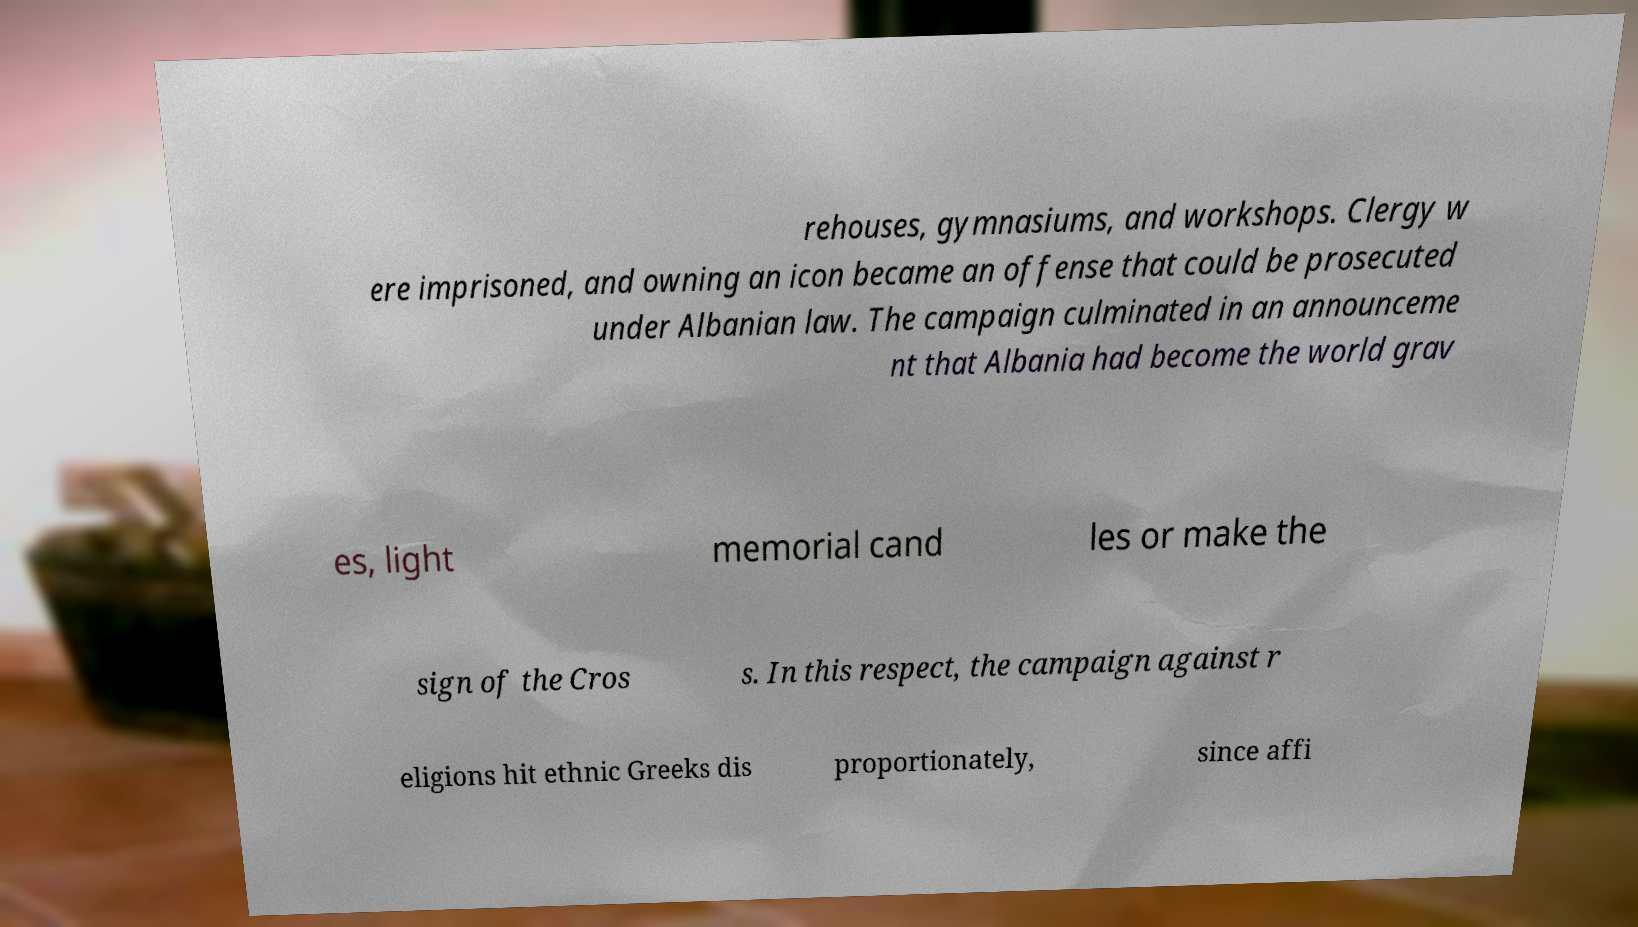Can you read and provide the text displayed in the image?This photo seems to have some interesting text. Can you extract and type it out for me? rehouses, gymnasiums, and workshops. Clergy w ere imprisoned, and owning an icon became an offense that could be prosecuted under Albanian law. The campaign culminated in an announceme nt that Albania had become the world grav es, light memorial cand les or make the sign of the Cros s. In this respect, the campaign against r eligions hit ethnic Greeks dis proportionately, since affi 